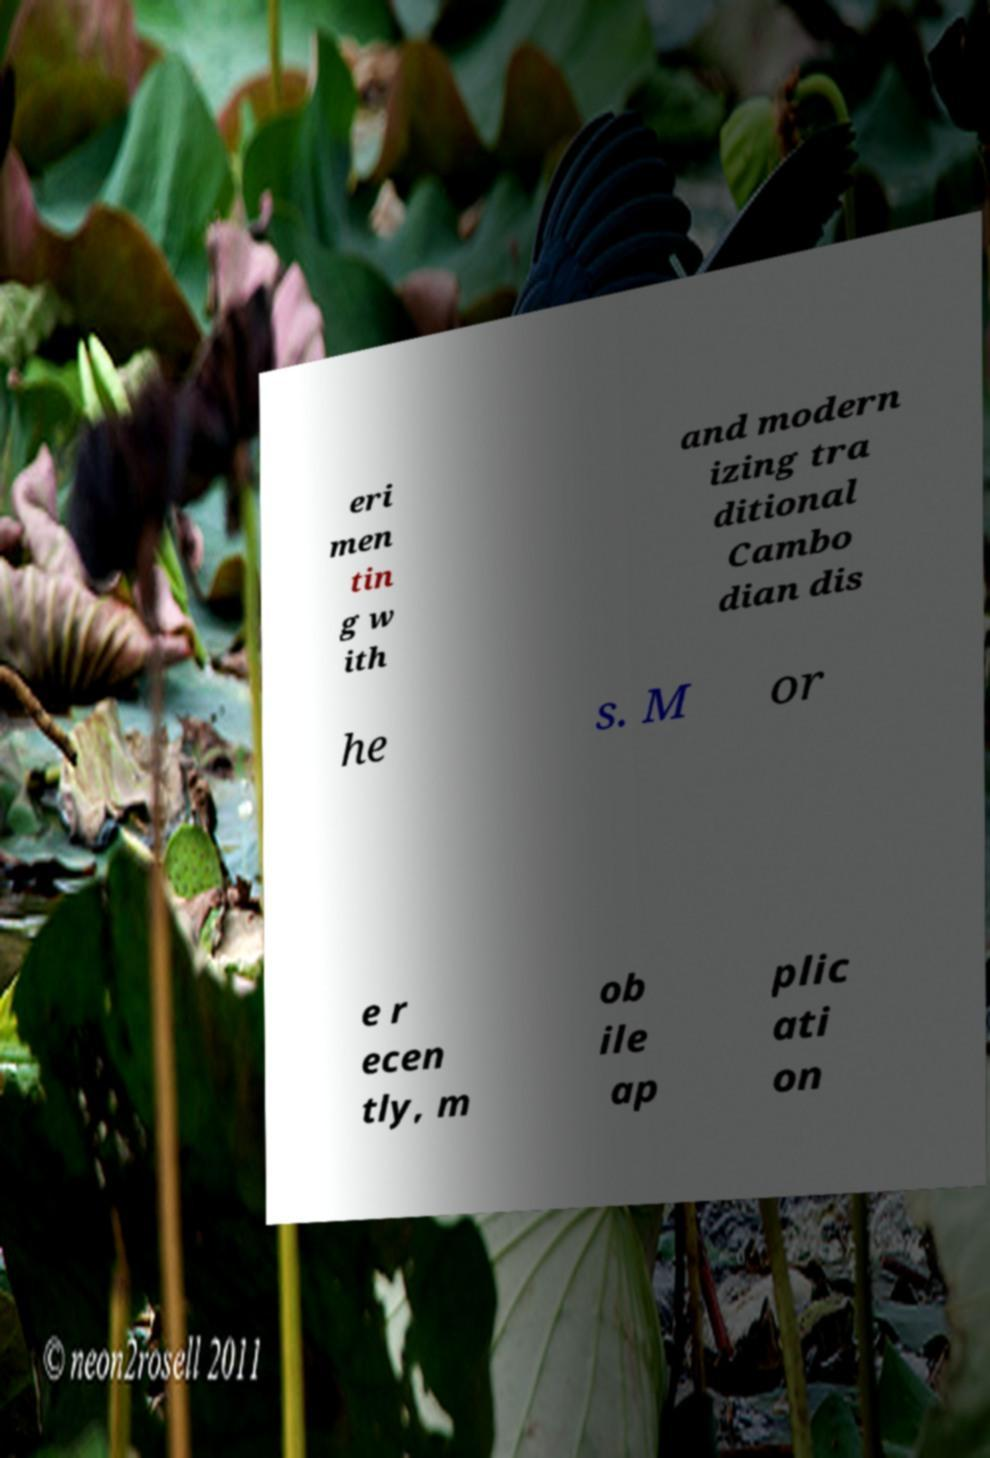What messages or text are displayed in this image? I need them in a readable, typed format. eri men tin g w ith and modern izing tra ditional Cambo dian dis he s. M or e r ecen tly, m ob ile ap plic ati on 